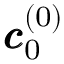<formula> <loc_0><loc_0><loc_500><loc_500>\pm b { c } _ { 0 } ^ { ( 0 ) }</formula> 